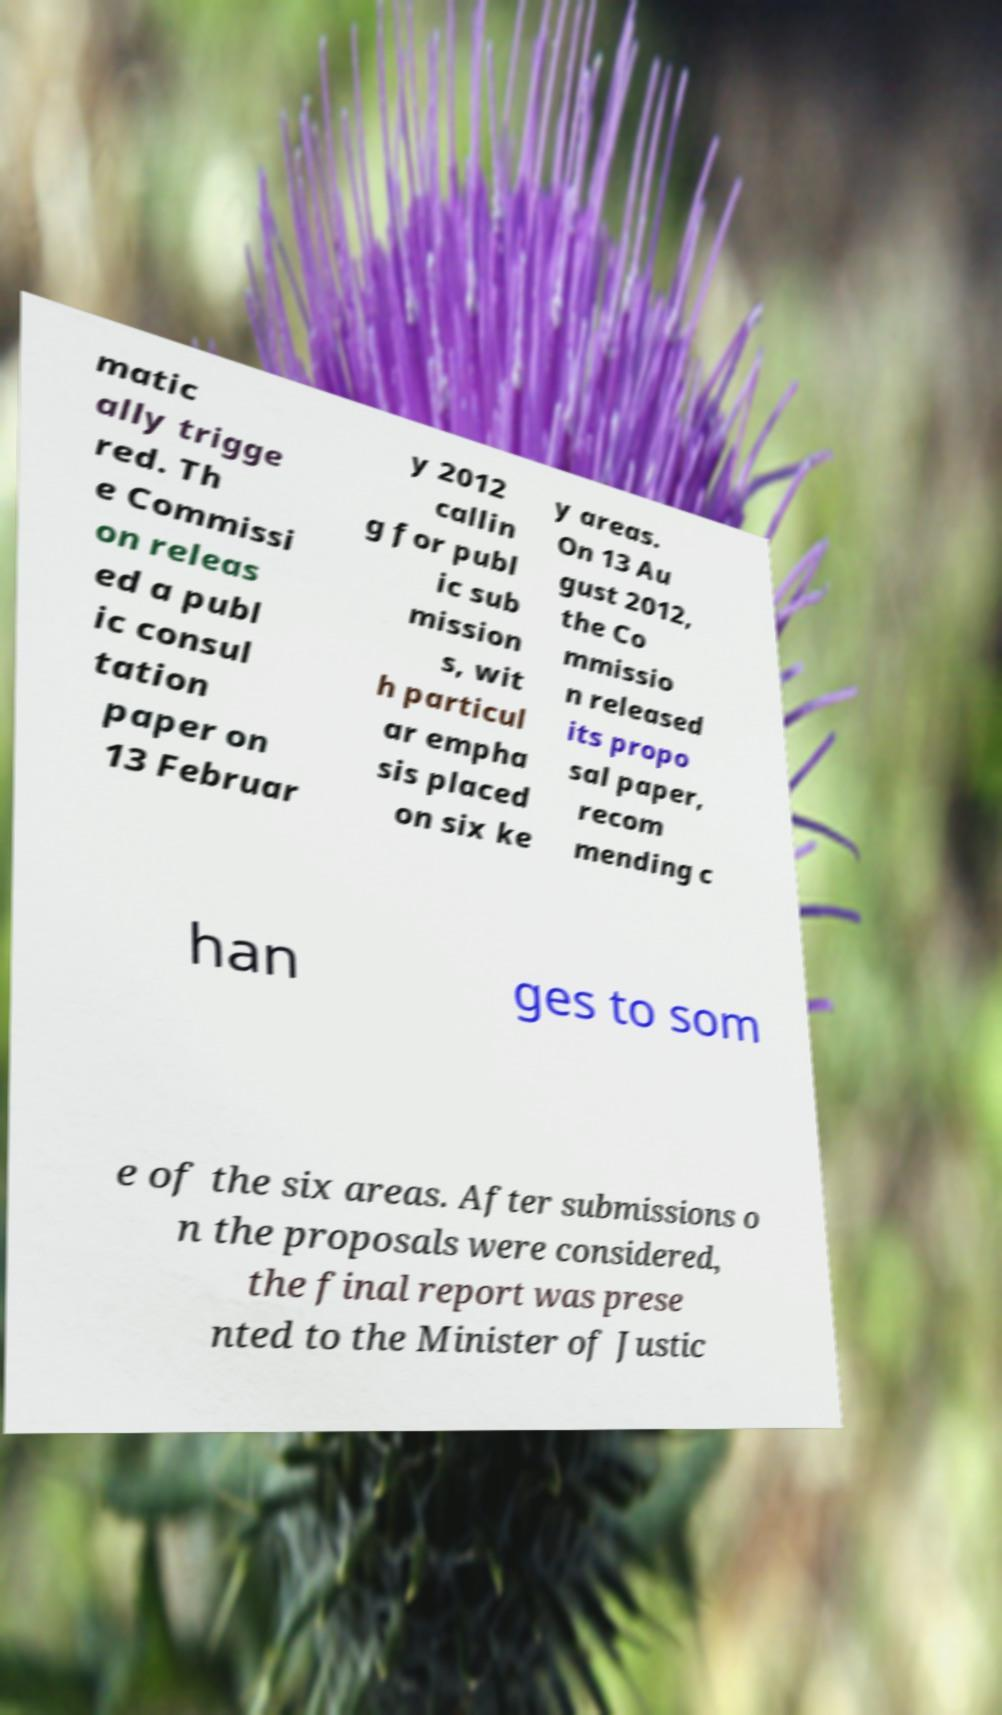I need the written content from this picture converted into text. Can you do that? matic ally trigge red. Th e Commissi on releas ed a publ ic consul tation paper on 13 Februar y 2012 callin g for publ ic sub mission s, wit h particul ar empha sis placed on six ke y areas. On 13 Au gust 2012, the Co mmissio n released its propo sal paper, recom mending c han ges to som e of the six areas. After submissions o n the proposals were considered, the final report was prese nted to the Minister of Justic 